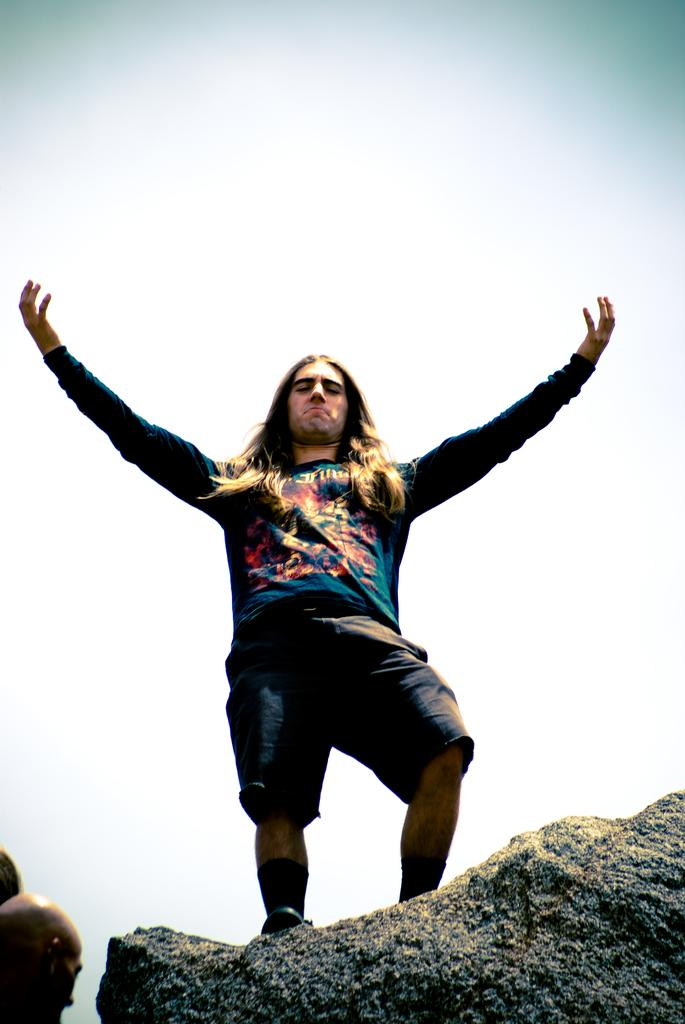Who is the main subject in the image? There is a man standing in the center of the image. What is located at the bottom of the image? There is a rock at the bottom of the image, and there are also people present. What can be seen in the background of the image? The sky is visible in the background of the image. What type of list can be seen hanging from the edge of the rock in the image? There is no list present in the image, and the edge of the rock is not mentioned in the provided facts. 